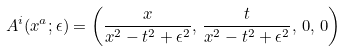Convert formula to latex. <formula><loc_0><loc_0><loc_500><loc_500>A ^ { i } ( x ^ { a } ; \epsilon ) = \left ( \frac { x } { x ^ { 2 } - t ^ { 2 } + \epsilon ^ { 2 } } , \, \frac { t } { x ^ { 2 } - t ^ { 2 } + \epsilon ^ { 2 } } , \, 0 , \, 0 \right )</formula> 